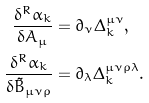Convert formula to latex. <formula><loc_0><loc_0><loc_500><loc_500>\frac { \delta ^ { R } \alpha _ { k } } { \delta A _ { \mu } } & = \partial _ { \nu } \Delta _ { k } ^ { \mu \nu } , \\ \frac { \delta ^ { R } \alpha _ { k } } { \delta \tilde { B } _ { \mu \nu \rho } } & = \partial _ { \lambda } \Delta _ { k } ^ { \mu \nu \rho \lambda } .</formula> 